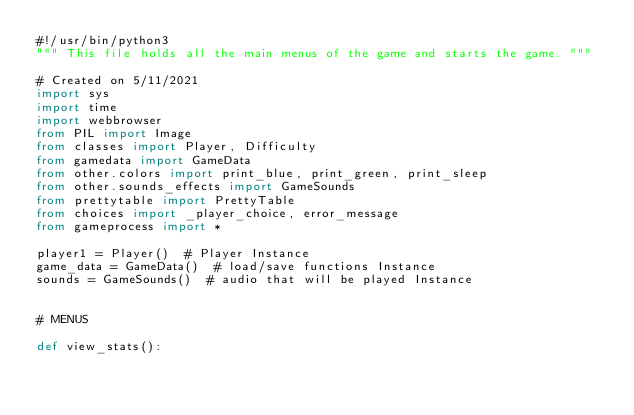Convert code to text. <code><loc_0><loc_0><loc_500><loc_500><_Python_>#!/usr/bin/python3
""" This file holds all the main menus of the game and starts the game. """

# Created on 5/11/2021
import sys
import time
import webbrowser
from PIL import Image
from classes import Player, Difficulty
from gamedata import GameData
from other.colors import print_blue, print_green, print_sleep
from other.sounds_effects import GameSounds
from prettytable import PrettyTable
from choices import _player_choice, error_message
from gameprocess import *

player1 = Player()  # Player Instance
game_data = GameData()  # load/save functions Instance
sounds = GameSounds()  # audio that will be played Instance


# MENUS

def view_stats():</code> 